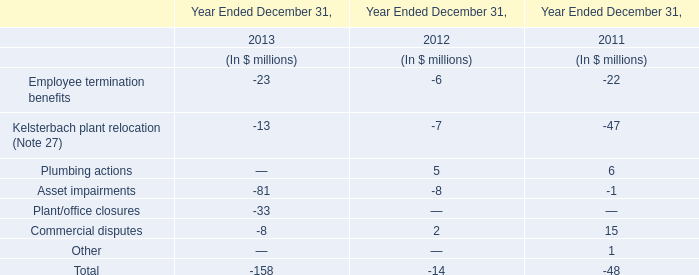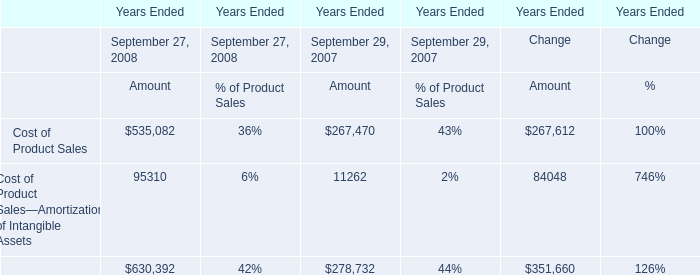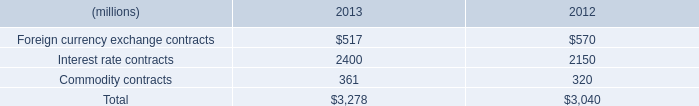what's the total amount of Cost of Product Sales of Years Ended Change Amount, and Interest rate contracts of 2013 ? 
Computations: (267612.0 + 2400.0)
Answer: 270012.0. 